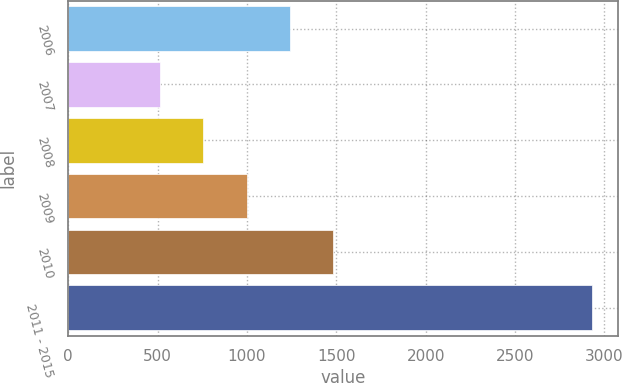<chart> <loc_0><loc_0><loc_500><loc_500><bar_chart><fcel>2006<fcel>2007<fcel>2008<fcel>2009<fcel>2010<fcel>2011 - 2015<nl><fcel>1240.1<fcel>515<fcel>756.7<fcel>998.4<fcel>1481.8<fcel>2932<nl></chart> 